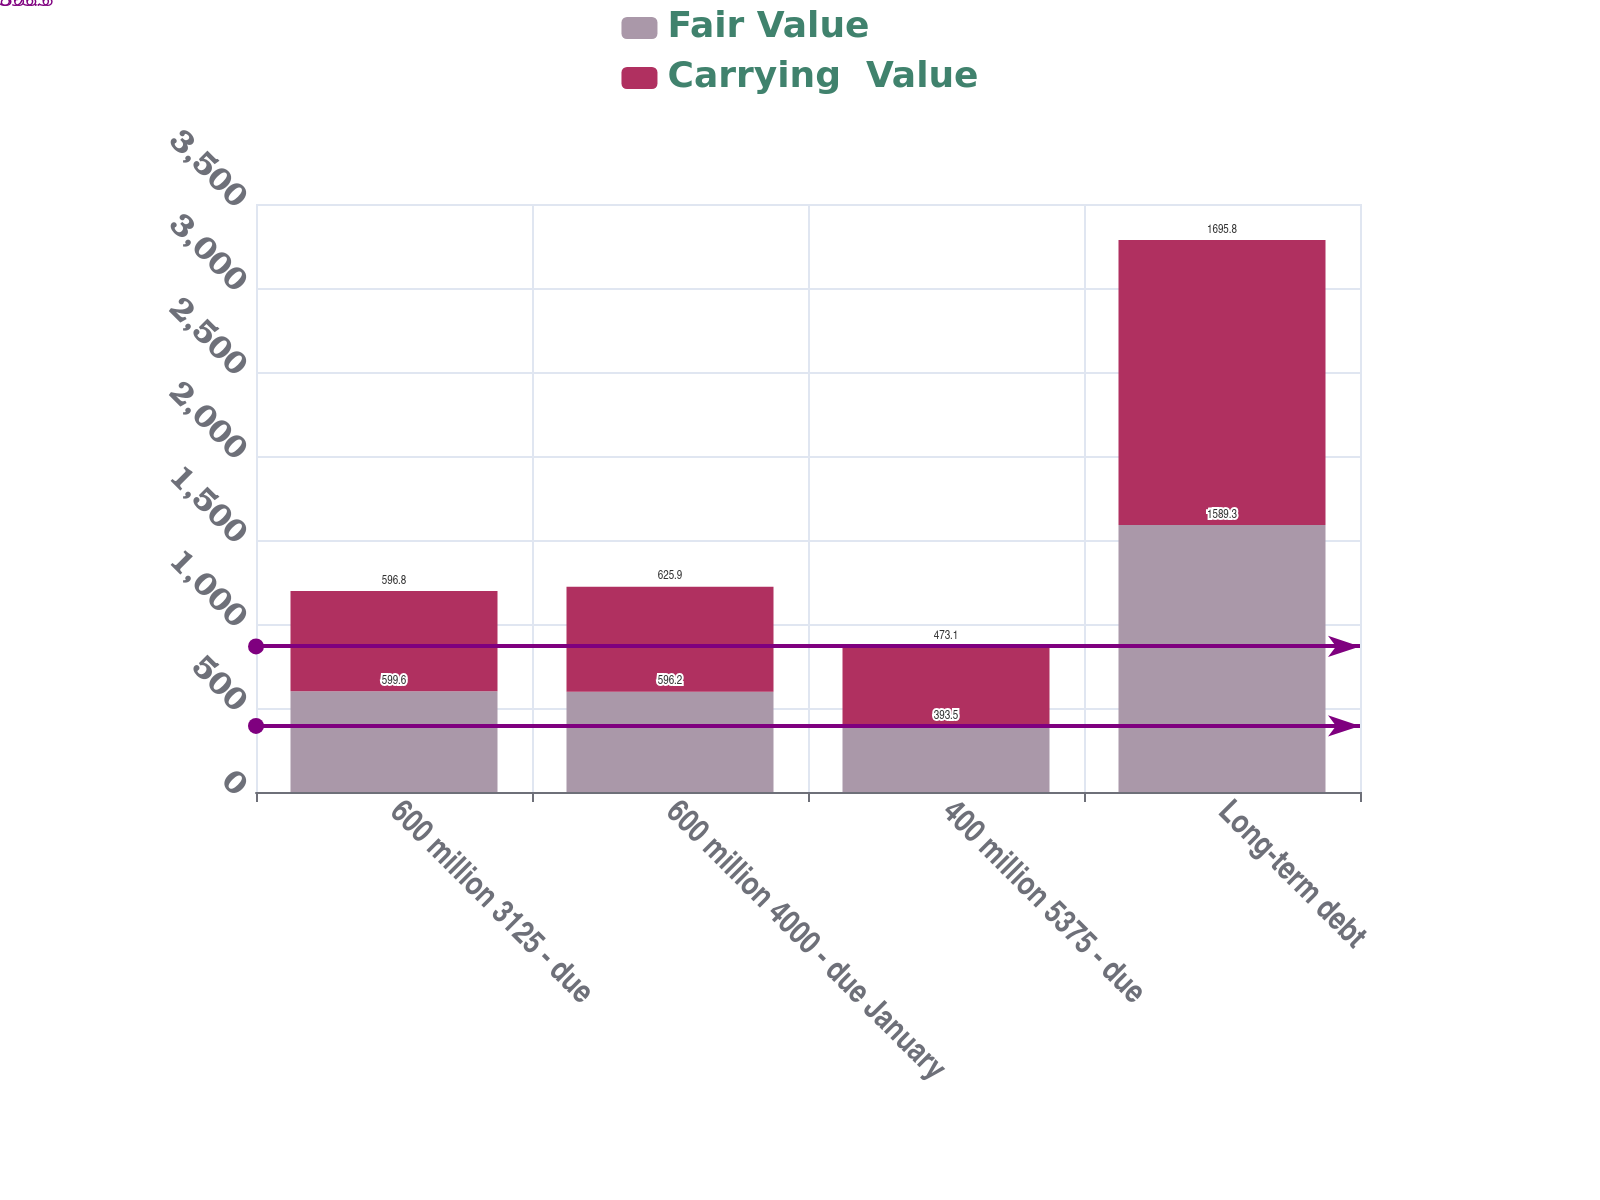<chart> <loc_0><loc_0><loc_500><loc_500><stacked_bar_chart><ecel><fcel>600 million 3125 - due<fcel>600 million 4000 - due January<fcel>400 million 5375 - due<fcel>Long-term debt<nl><fcel>Fair Value<fcel>599.6<fcel>596.2<fcel>393.5<fcel>1589.3<nl><fcel>Carrying  Value<fcel>596.8<fcel>625.9<fcel>473.1<fcel>1695.8<nl></chart> 